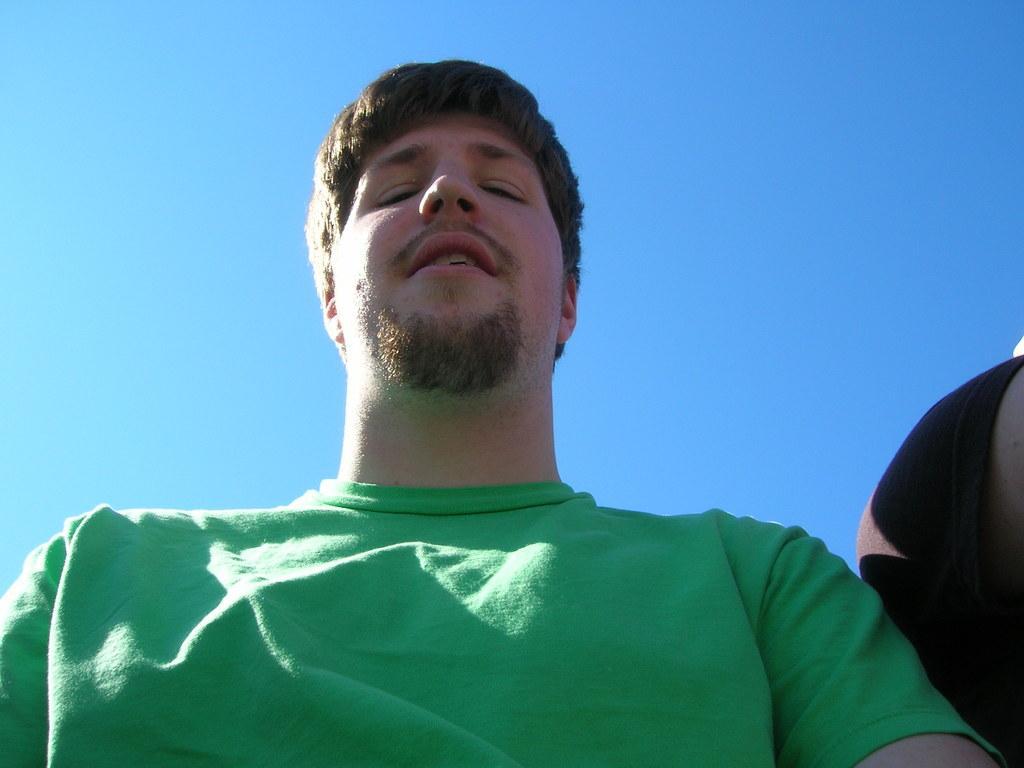How would you summarize this image in a sentence or two? In this image there is a man wearing green T-shirt, in the background there is the sky. 